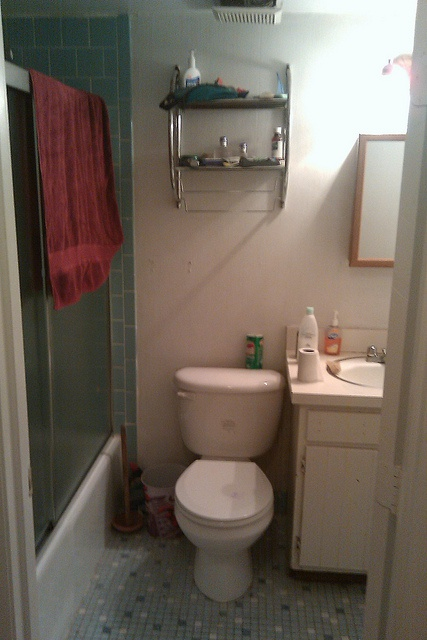Describe the objects in this image and their specific colors. I can see toilet in gray and darkgray tones, sink in gray, tan, and lightgray tones, bottle in gray and tan tones, bottle in gray, darkgray, and lightgray tones, and bottle in gray, white, and darkgray tones in this image. 